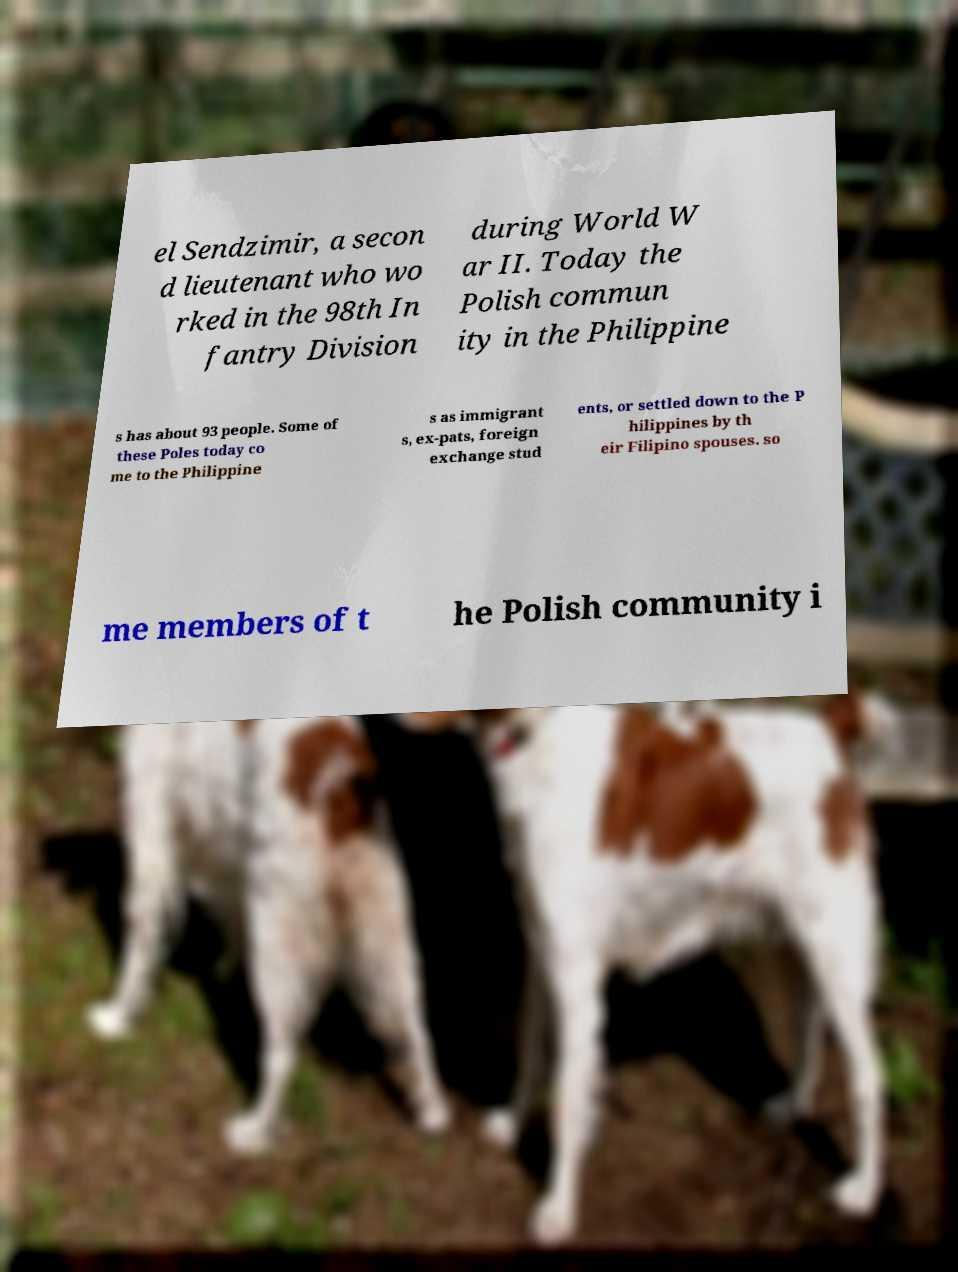Could you assist in decoding the text presented in this image and type it out clearly? el Sendzimir, a secon d lieutenant who wo rked in the 98th In fantry Division during World W ar II. Today the Polish commun ity in the Philippine s has about 93 people. Some of these Poles today co me to the Philippine s as immigrant s, ex-pats, foreign exchange stud ents, or settled down to the P hilippines by th eir Filipino spouses. so me members of t he Polish community i 